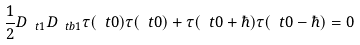<formula> <loc_0><loc_0><loc_500><loc_500>\frac { 1 } { 2 } D _ { \ t 1 } D _ { \ t b 1 } \tau ( \ t 0 ) \tau ( \ t 0 ) + \tau ( \ t 0 + \hbar { ) } \tau ( \ t 0 - \hbar { ) } = 0</formula> 